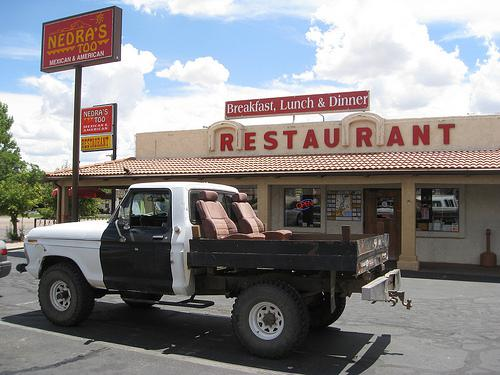Question: who's restaurant is this?
Choices:
A. Nedra.
B. Kimberly.
C. Timothy.
D. Marilyn.
Answer with the letter. Answer: A Question: what color are the letters in restaurant?
Choices:
A. Red.
B. Blue.
C. Black.
D. White.
Answer with the letter. Answer: A Question: how many restaurants are there?
Choices:
A. One.
B. Five.
C. Two.
D. Four.
Answer with the letter. Answer: A 